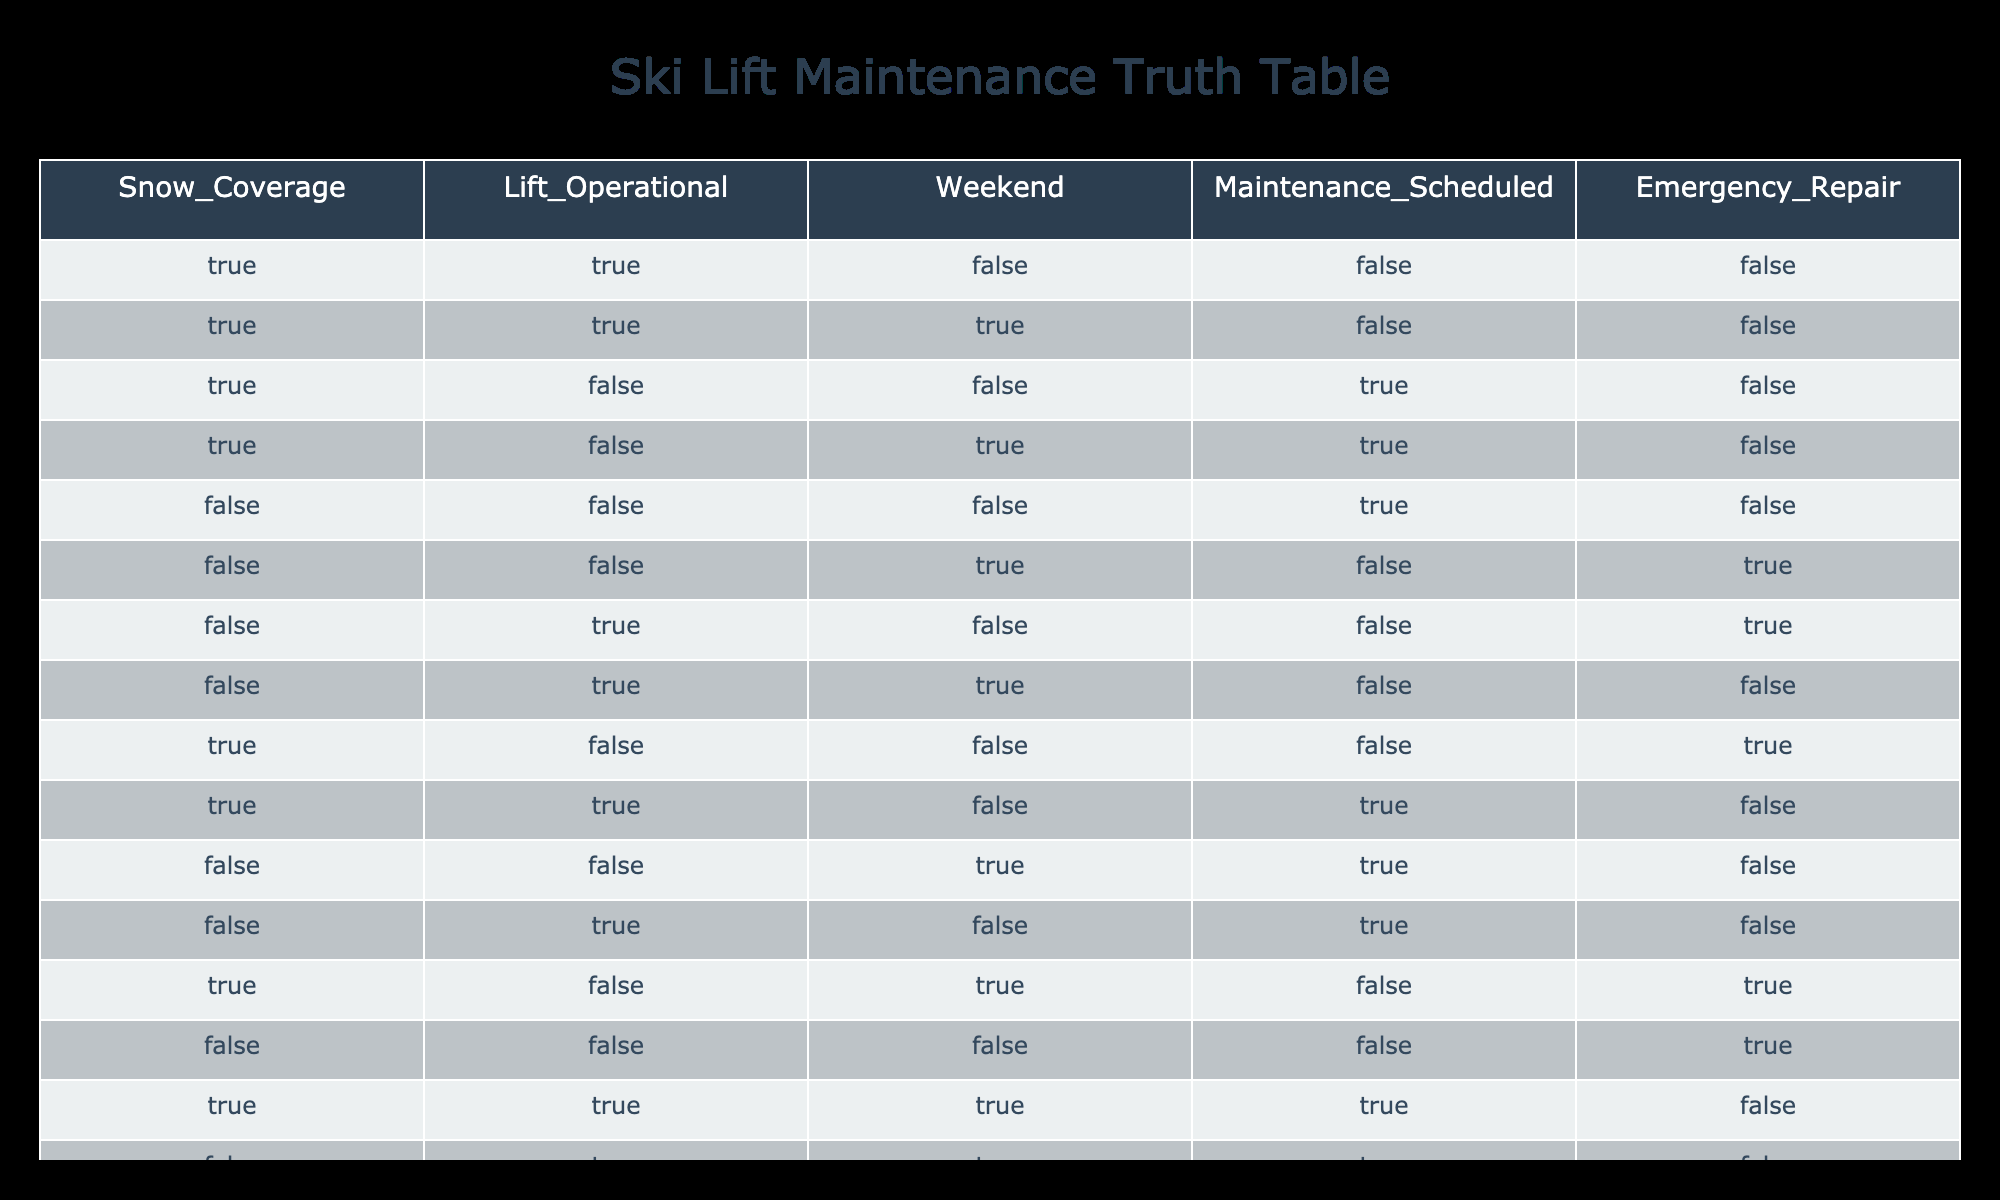What is the total number of rows where the lift is operational? By examining the "Lift_Operational" column, we find that there are 6 rows where the value is True: (True, True, False, True, True, True). Therefore, the total count is 6.
Answer: 6 How many rows have snow coverage and no maintenance scheduled? We need to find rows where "Snow_Coverage" is True and "Maintenance_Scheduled" is False. Upon inspection, these rows are: (True, True, False, False). That's a total of 3 rows.
Answer: 3 Is there a scenario where the lift is operational and maintenance is scheduled at the same time? Looking at the table, there are no instances where both "Lift_Operational" is True and "Maintenance_Scheduled" is True simultaneously. Therefore, the answer is no.
Answer: No What is the average number of emergency repairs scheduled corresponding to weekends? To find the average, first identify non-zero instances: there are 2 occurrences on weekends (rows 3 and 5 where Emergency_Repair is True). The total for weekends having emergency repairs is 2, and the count of weekend rows is 6, giving an average of 2/6.
Answer: Approximately 0.33 Are there more instances of emergency repairs scheduled during weekends compared to weekdays? We first total the emergency repairs on weekends (True for Weekend) versus weekdays. There are 2 for weekends (rows 5 and 10) and 5 on weekdays (rows 1, 3, 4, 8, 12). Since 5 is greater than 2, there are more emergency repairs scheduled during weekdays.
Answer: Yes During which time is the maintenance most frequently scheduled, weekends or weekdays? Counting "Maintenance_Scheduled" on weekends (True for Weekend): rows 3, 4, 10, 11, 14 have True which sums to 4 instances. For weekdays (False for Weekend): we have rows 1, 5, 6, 7, 8, 9, 12, 13 giving a count of 8. Thus, weekdays have more scheduled maintenance.
Answer: Weekdays 